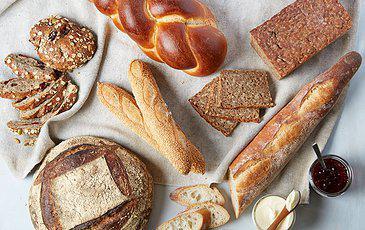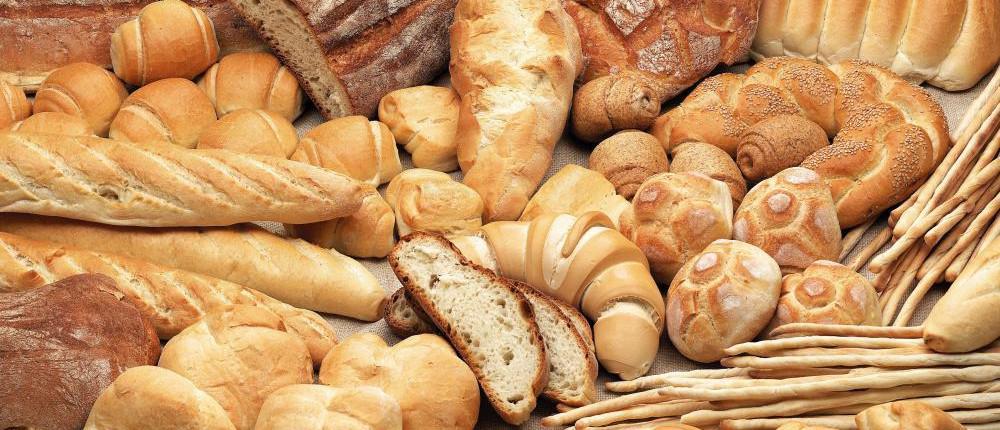The first image is the image on the left, the second image is the image on the right. For the images shown, is this caption "The left image includes multiple roundish baked loaves with a single slice-mark across the top, and they are not in a container." true? Answer yes or no. No. 